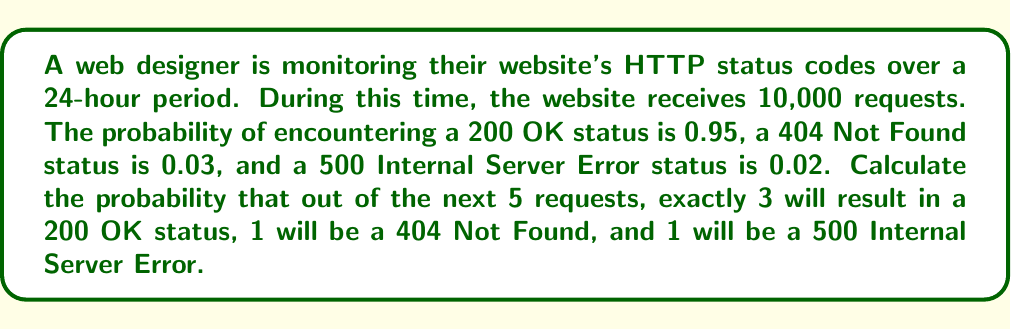Show me your answer to this math problem. To solve this problem, we'll use the multinomial probability distribution, which is an extension of the binomial distribution for more than two outcomes.

Step 1: Identify the probabilities for each outcome
$p_{200} = 0.95$ (probability of 200 OK)
$p_{404} = 0.03$ (probability of 404 Not Found)
$p_{500} = 0.02$ (probability of 500 Internal Server Error)

Step 2: Set up the multinomial probability formula
The general formula for multinomial probability is:

$$P(X_1 = k_1, X_2 = k_2, ..., X_m = k_m) = \frac{n!}{k_1! k_2! ... k_m!} p_1^{k_1} p_2^{k_2} ... p_m^{k_m}$$

Where:
$n$ is the total number of trials (5 in this case)
$k_i$ is the number of occurrences for each outcome
$p_i$ is the probability of each outcome

Step 3: Plug in the values
$n = 5$
$k_{200} = 3$, $k_{404} = 1$, $k_{500} = 1$
$p_{200} = 0.95$, $p_{404} = 0.03$, $p_{500} = 0.02$

$$P(X_{200} = 3, X_{404} = 1, X_{500} = 1) = \frac{5!}{3! 1! 1!} (0.95)^3 (0.03)^1 (0.02)^1$$

Step 4: Calculate
$$P(X_{200} = 3, X_{404} = 1, X_{500} = 1) = 20 \times 0.857375 \times 0.03 \times 0.02$$
$$P(X_{200} = 3, X_{404} = 1, X_{500} = 1) = 0.0102885$$

Therefore, the probability of exactly 3 200 OK status, 1 404 Not Found status, and 1 500 Internal Server Error status in the next 5 requests is approximately 0.0102885 or about 1.03%.
Answer: 0.0102885 